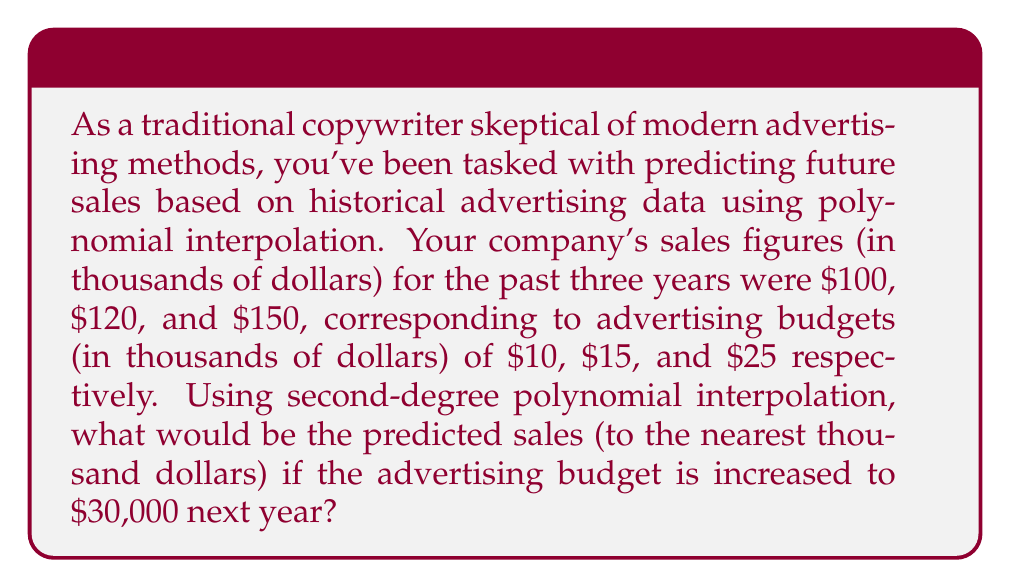Solve this math problem. Let's approach this step-by-step using polynomial interpolation:

1) We have three data points: $(10, 100)$, $(15, 120)$, and $(25, 150)$.

2) We'll use the Lagrange interpolation formula to find a second-degree polynomial that passes through these points:

   $P(x) = y_1 \frac{(x-x_2)(x-x_3)}{(x_1-x_2)(x_1-x_3)} + y_2 \frac{(x-x_1)(x-x_3)}{(x_2-x_1)(x_2-x_3)} + y_3 \frac{(x-x_1)(x-x_2)}{(x_3-x_1)(x_3-x_2)}$

3) Substituting our values:

   $P(x) = 100 \frac{(x-15)(x-25)}{(10-15)(10-25)} + 120 \frac{(x-10)(x-25)}{(15-10)(15-25)} + 150 \frac{(x-10)(x-15)}{(25-10)(25-15)}$

4) Simplifying:

   $P(x) = 100 \frac{(x-15)(x-25)}{(-5)(-15)} + 120 \frac{(x-10)(x-25)}{(5)(-10)} + 150 \frac{(x-10)(x-15)}{(15)(10)}$

   $P(x) = \frac{100(x^2-40x+375)}{75} - \frac{120(x^2-35x+250)}{50} + \frac{150(x^2-25x+150)}{150}$

5) Combining terms:

   $P(x) = \frac{4x^2-160x+1500}{3} - \frac{12x^2-420x+3000}{5} + x^2-25x+150$

6) Simplifying further:

   $P(x) = \frac{20x^2-800x+7500}{15} - \frac{36x^2-1260x+9000}{15} + \frac{15x^2-375x+2250}{15}$

   $P(x) = \frac{-x^2+85x+750}{15}$

7) Now, we need to evaluate $P(30)$:

   $P(30) = \frac{-30^2+85(30)+750}{15} = \frac{-900+2550+750}{15} = \frac{2400}{15} = 160$

Therefore, the predicted sales for an advertising budget of $30,000 is $160,000.
Answer: $160,000 